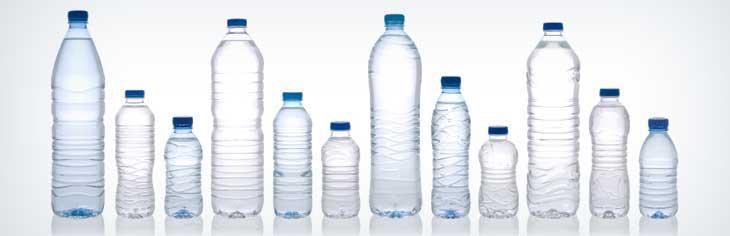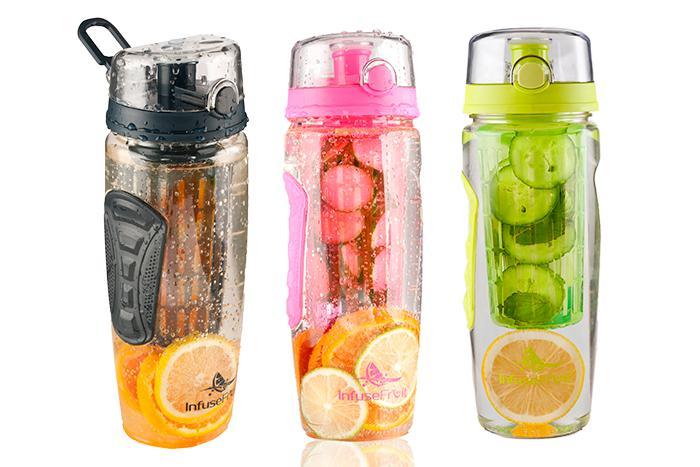The first image is the image on the left, the second image is the image on the right. Considering the images on both sides, is "At least one container contains some slices of fruit in it." valid? Answer yes or no. Yes. The first image is the image on the left, the second image is the image on the right. For the images displayed, is the sentence "There is at least one bottle with fruit and water in it." factually correct? Answer yes or no. Yes. 